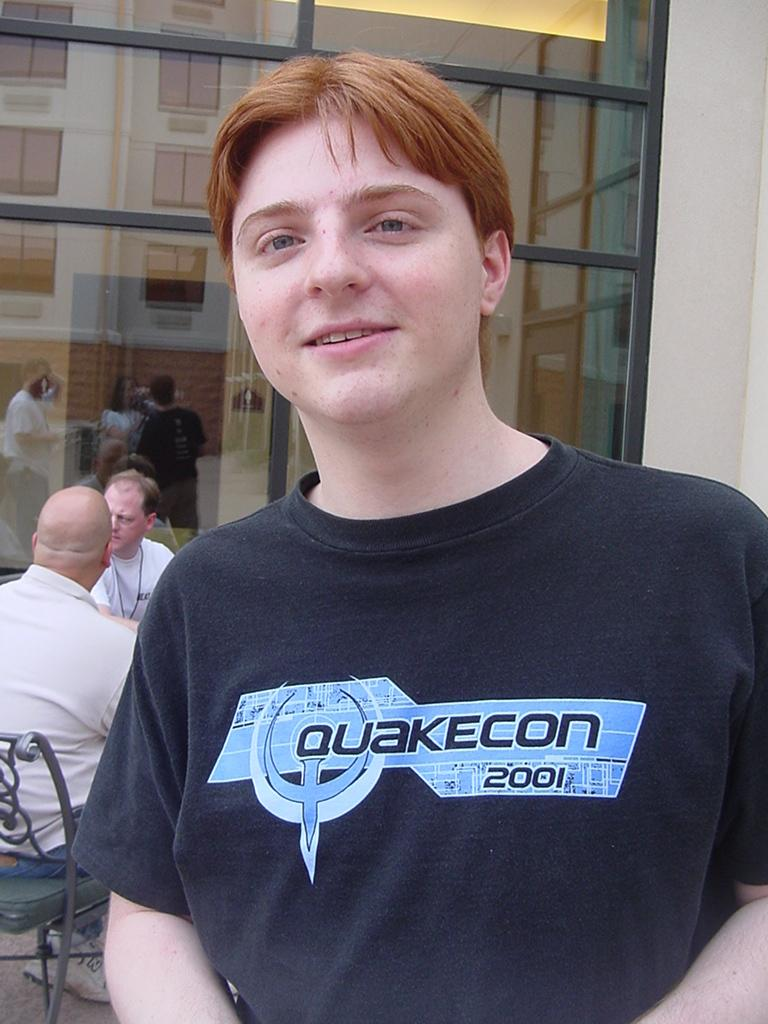<image>
Relay a brief, clear account of the picture shown. Outside of a building with large glass windows, is a young man wearing a Quakecon 2001 T-shirt. 